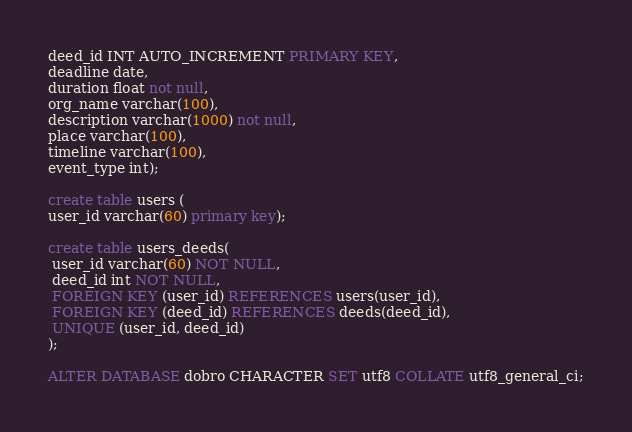<code> <loc_0><loc_0><loc_500><loc_500><_SQL_>deed_id INT AUTO_INCREMENT PRIMARY KEY,
deadline date,
duration float not null,
org_name varchar(100),
description varchar(1000) not null,
place varchar(100),
timeline varchar(100),
event_type int);

create table users (
user_id varchar(60) primary key);

create table users_deeds(
 user_id varchar(60) NOT NULL,
 deed_id int NOT NULL,
 FOREIGN KEY (user_id) REFERENCES users(user_id), 
 FOREIGN KEY (deed_id) REFERENCES deeds(deed_id),
 UNIQUE (user_id, deed_id)  
);

ALTER DATABASE dobro CHARACTER SET utf8 COLLATE utf8_general_ci;




</code> 